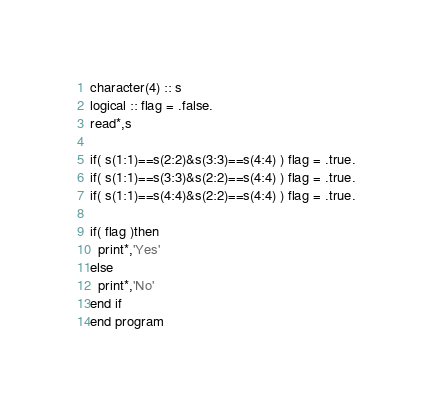<code> <loc_0><loc_0><loc_500><loc_500><_FORTRAN_>character(4) :: s
logical :: flag = .false.
read*,s

if( s(1:1)==s(2:2)&s(3:3)==s(4:4) ) flag = .true.
if( s(1:1)==s(3:3)&s(2:2)==s(4:4) ) flag = .true.
if( s(1:1)==s(4:4)&s(2:2)==s(4:4) ) flag = .true.

if( flag )then
  print*,'Yes'
else
  print*,'No'
end if
end program
</code> 